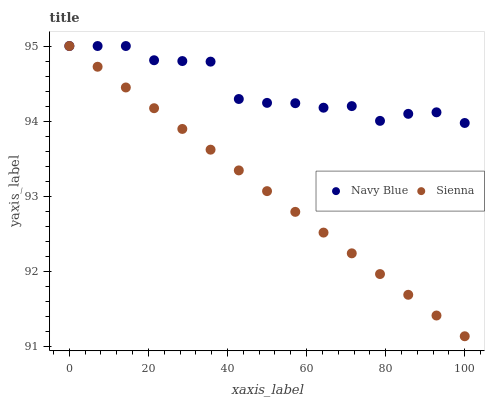Does Sienna have the minimum area under the curve?
Answer yes or no. Yes. Does Navy Blue have the maximum area under the curve?
Answer yes or no. Yes. Does Navy Blue have the minimum area under the curve?
Answer yes or no. No. Is Sienna the smoothest?
Answer yes or no. Yes. Is Navy Blue the roughest?
Answer yes or no. Yes. Is Navy Blue the smoothest?
Answer yes or no. No. Does Sienna have the lowest value?
Answer yes or no. Yes. Does Navy Blue have the lowest value?
Answer yes or no. No. Does Navy Blue have the highest value?
Answer yes or no. Yes. Does Sienna intersect Navy Blue?
Answer yes or no. Yes. Is Sienna less than Navy Blue?
Answer yes or no. No. Is Sienna greater than Navy Blue?
Answer yes or no. No. 